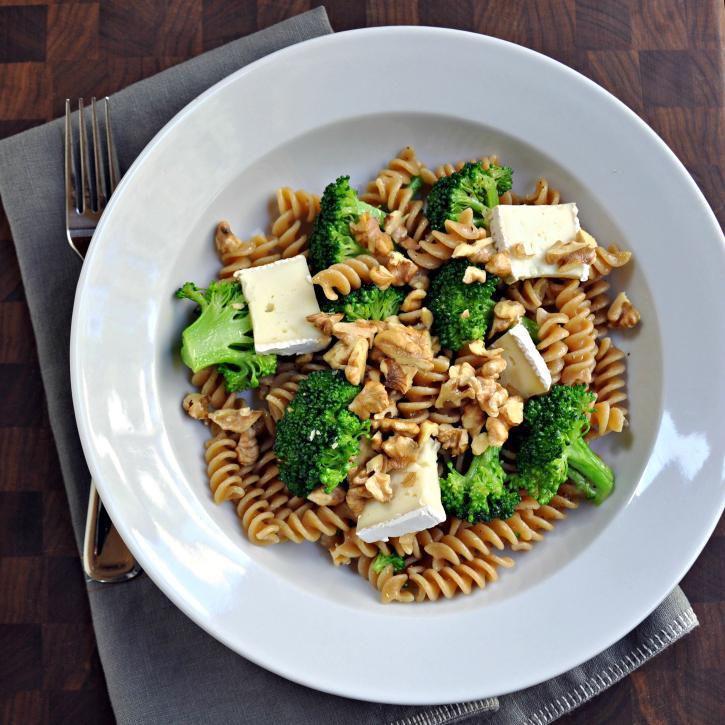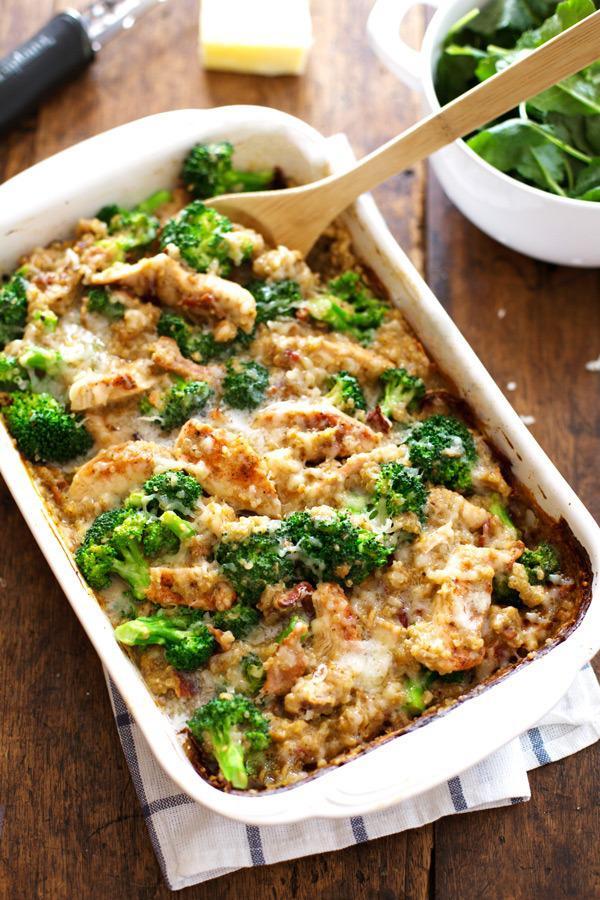The first image is the image on the left, the second image is the image on the right. Given the left and right images, does the statement "One image shows a casserole with a wooden serving spoon, and the other image is at least one individual serving of casserole in a white bowl." hold true? Answer yes or no. Yes. The first image is the image on the left, the second image is the image on the right. For the images displayed, is the sentence "A wooden spoon sits in a container of food." factually correct? Answer yes or no. Yes. 